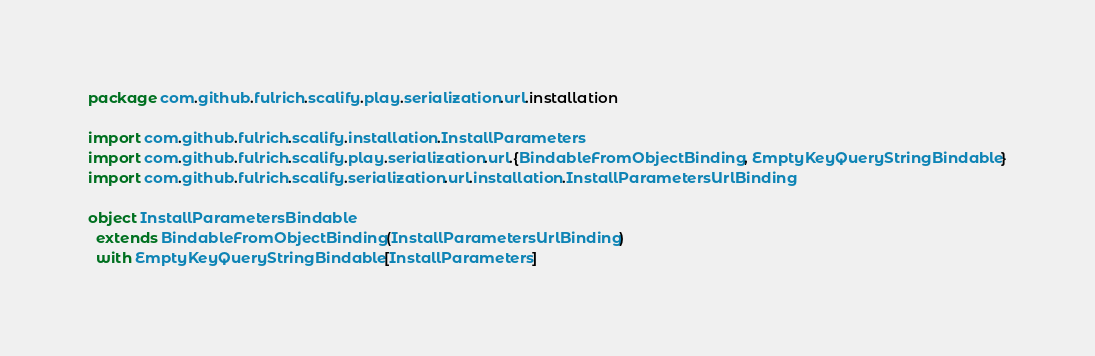Convert code to text. <code><loc_0><loc_0><loc_500><loc_500><_Scala_>package com.github.fulrich.scalify.play.serialization.url.installation

import com.github.fulrich.scalify.installation.InstallParameters
import com.github.fulrich.scalify.play.serialization.url.{BindableFromObjectBinding, EmptyKeyQueryStringBindable}
import com.github.fulrich.scalify.serialization.url.installation.InstallParametersUrlBinding

object InstallParametersBindable
  extends BindableFromObjectBinding(InstallParametersUrlBinding)
  with EmptyKeyQueryStringBindable[InstallParameters]
</code> 